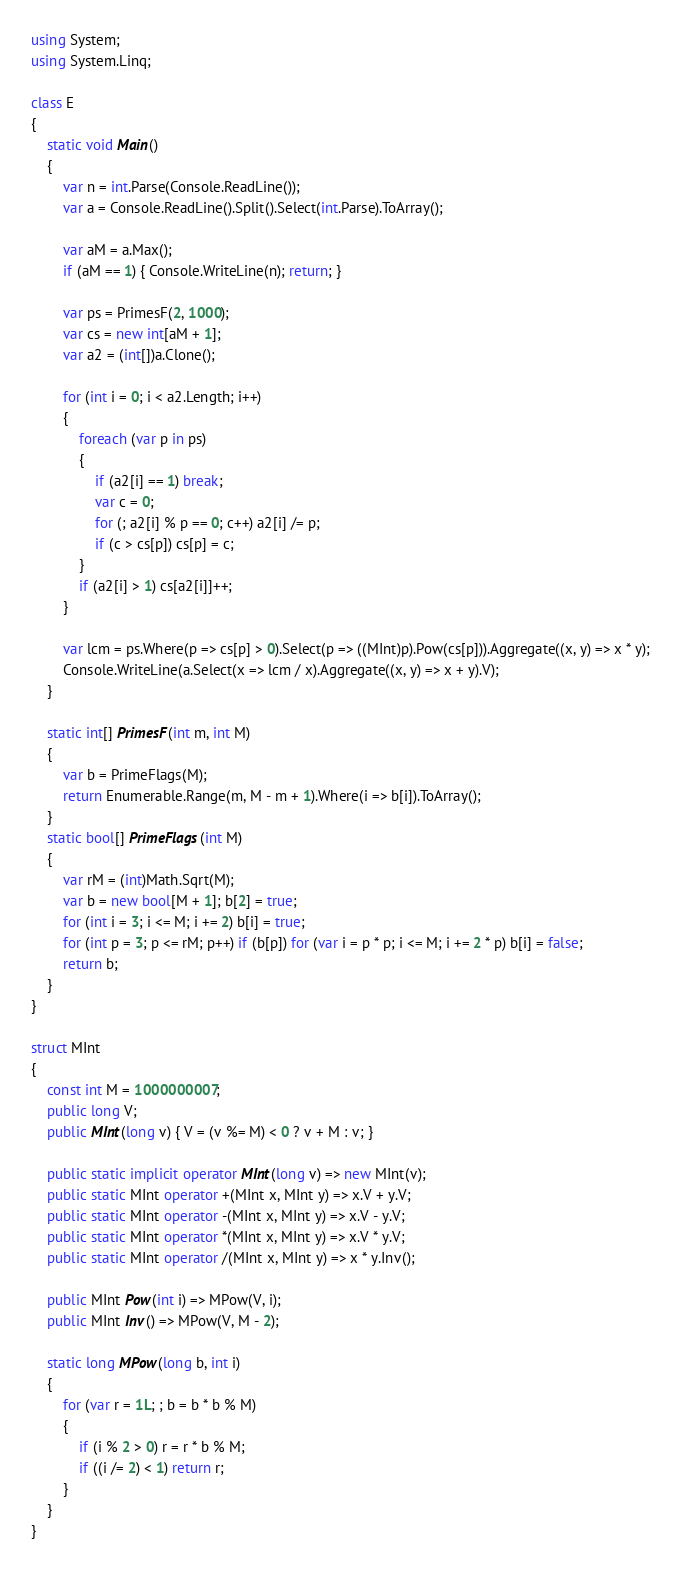Convert code to text. <code><loc_0><loc_0><loc_500><loc_500><_C#_>using System;
using System.Linq;

class E
{
	static void Main()
	{
		var n = int.Parse(Console.ReadLine());
		var a = Console.ReadLine().Split().Select(int.Parse).ToArray();

		var aM = a.Max();
		if (aM == 1) { Console.WriteLine(n); return; }

		var ps = PrimesF(2, 1000);
		var cs = new int[aM + 1];
		var a2 = (int[])a.Clone();

		for (int i = 0; i < a2.Length; i++)
		{
			foreach (var p in ps)
			{
				if (a2[i] == 1) break;
				var c = 0;
				for (; a2[i] % p == 0; c++) a2[i] /= p;
				if (c > cs[p]) cs[p] = c;
			}
			if (a2[i] > 1) cs[a2[i]]++;
		}

		var lcm = ps.Where(p => cs[p] > 0).Select(p => ((MInt)p).Pow(cs[p])).Aggregate((x, y) => x * y);
		Console.WriteLine(a.Select(x => lcm / x).Aggregate((x, y) => x + y).V);
	}

	static int[] PrimesF(int m, int M)
	{
		var b = PrimeFlags(M);
		return Enumerable.Range(m, M - m + 1).Where(i => b[i]).ToArray();
	}
	static bool[] PrimeFlags(int M)
	{
		var rM = (int)Math.Sqrt(M);
		var b = new bool[M + 1]; b[2] = true;
		for (int i = 3; i <= M; i += 2) b[i] = true;
		for (int p = 3; p <= rM; p++) if (b[p]) for (var i = p * p; i <= M; i += 2 * p) b[i] = false;
		return b;
	}
}

struct MInt
{
	const int M = 1000000007;
	public long V;
	public MInt(long v) { V = (v %= M) < 0 ? v + M : v; }

	public static implicit operator MInt(long v) => new MInt(v);
	public static MInt operator +(MInt x, MInt y) => x.V + y.V;
	public static MInt operator -(MInt x, MInt y) => x.V - y.V;
	public static MInt operator *(MInt x, MInt y) => x.V * y.V;
	public static MInt operator /(MInt x, MInt y) => x * y.Inv();

	public MInt Pow(int i) => MPow(V, i);
	public MInt Inv() => MPow(V, M - 2);

	static long MPow(long b, int i)
	{
		for (var r = 1L; ; b = b * b % M)
		{
			if (i % 2 > 0) r = r * b % M;
			if ((i /= 2) < 1) return r;
		}
	}
}
</code> 